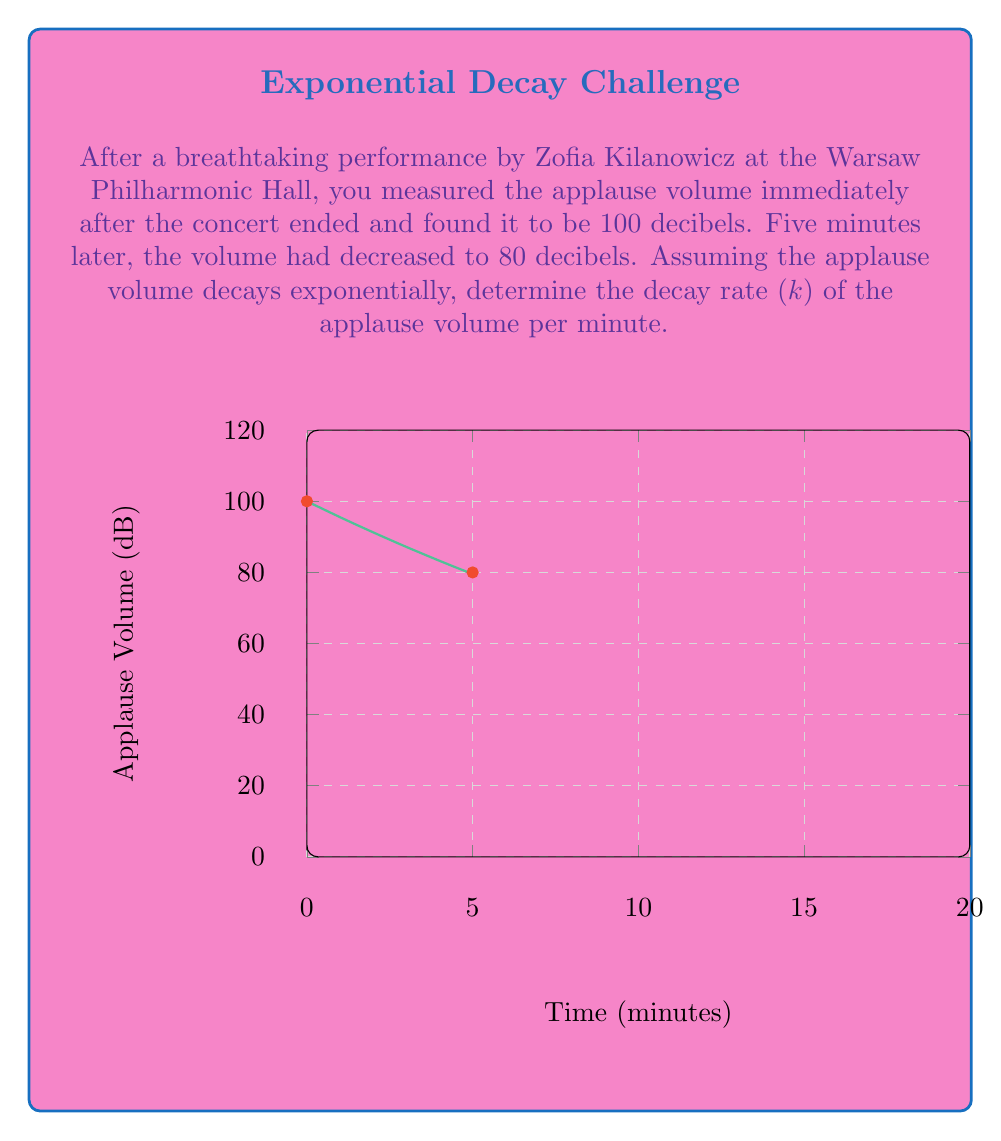What is the answer to this math problem? Let's approach this step-by-step using the exponential decay formula:

1) The general form of exponential decay is:
   $$A(t) = A_0 e^{-kt}$$
   where $A(t)$ is the amplitude at time $t$, $A_0$ is the initial amplitude, $k$ is the decay rate, and $t$ is time.

2) We know:
   - Initial volume $A_0 = 100$ dB
   - After 5 minutes, $A(5) = 80$ dB

3) Let's plug these values into our equation:
   $$80 = 100 e^{-k(5)}$$

4) Divide both sides by 100:
   $$0.8 = e^{-5k}$$

5) Take the natural log of both sides:
   $$\ln(0.8) = -5k$$

6) Solve for $k$:
   $$k = -\frac{\ln(0.8)}{5}$$

7) Calculate the value:
   $$k = -\frac{\ln(0.8)}{5} \approx 0.0446$$

Therefore, the decay rate is approximately 0.0446 per minute.
Answer: $k \approx 0.0446$ min^(-1) 